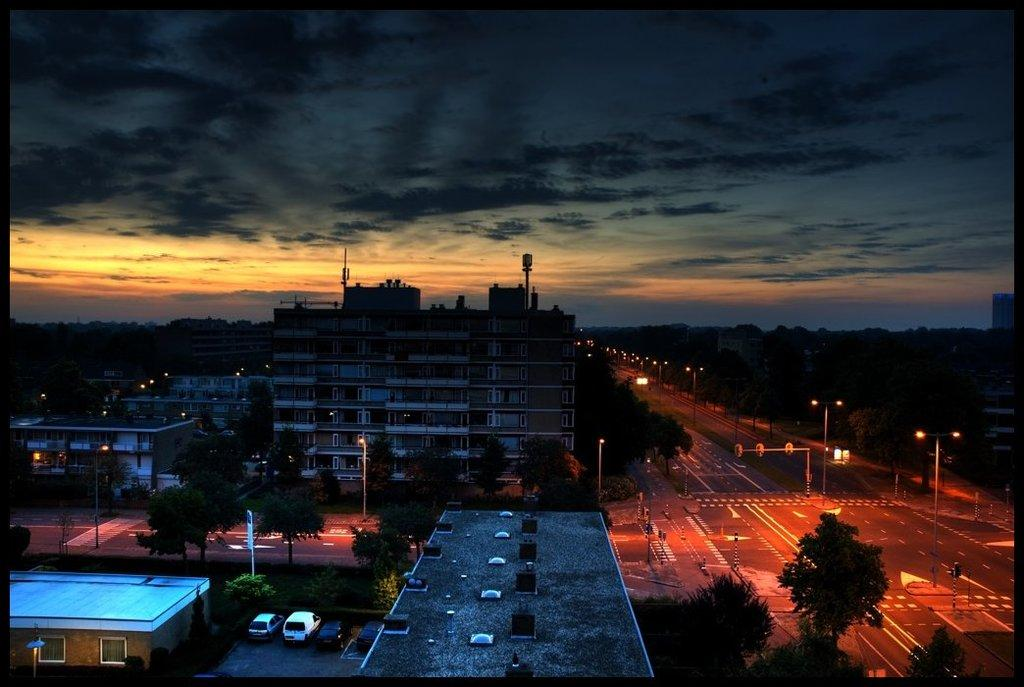What type of location is shown in the image? The image depicts a city. What are some of the main features of the city? There are plenty of buildings, cars, roads, and trees visible in the image. Can you describe any transportation methods in the image? Yes, there is at least one plane in the image, in addition to cars. How are the roads arranged in the image? The roads are present in the image, but their specific arrangement is not mentioned in the facts. What is the overall impression of the view in the image? The view is described as pleasant. What type of bread can be seen in the image? There is no bread present in the image; it depicts a city with various buildings, cars, roads, trees, and a plane. Which direction is the city facing in the image? The facts do not mention the direction the city is facing, so it cannot be determined from the image. 